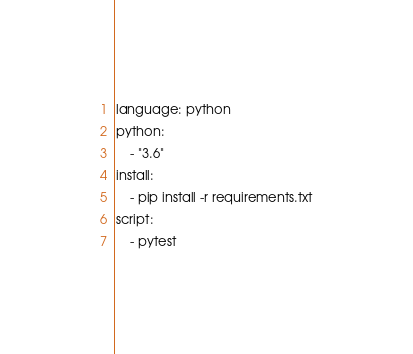<code> <loc_0><loc_0><loc_500><loc_500><_YAML_>language: python
python:
    - "3.6"
install:
    - pip install -r requirements.txt
script:
    - pytest
</code> 